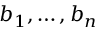<formula> <loc_0><loc_0><loc_500><loc_500>b _ { 1 } , \dots , b _ { n }</formula> 